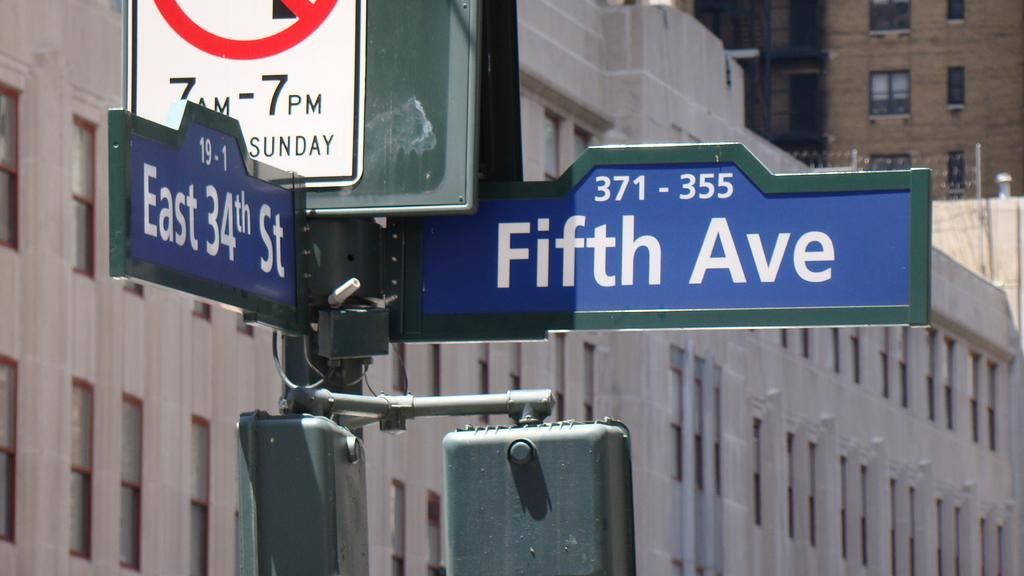What objects are attached to a pole in the image? There are boards attached to a pole in the image. What can be seen in the background of the image? There are buildings visible in the background of the image. What type of ray is visible in the image? There is no ray visible in the image. In which direction are the boards facing in the image? The direction the boards are facing cannot be determined from the image alone. 